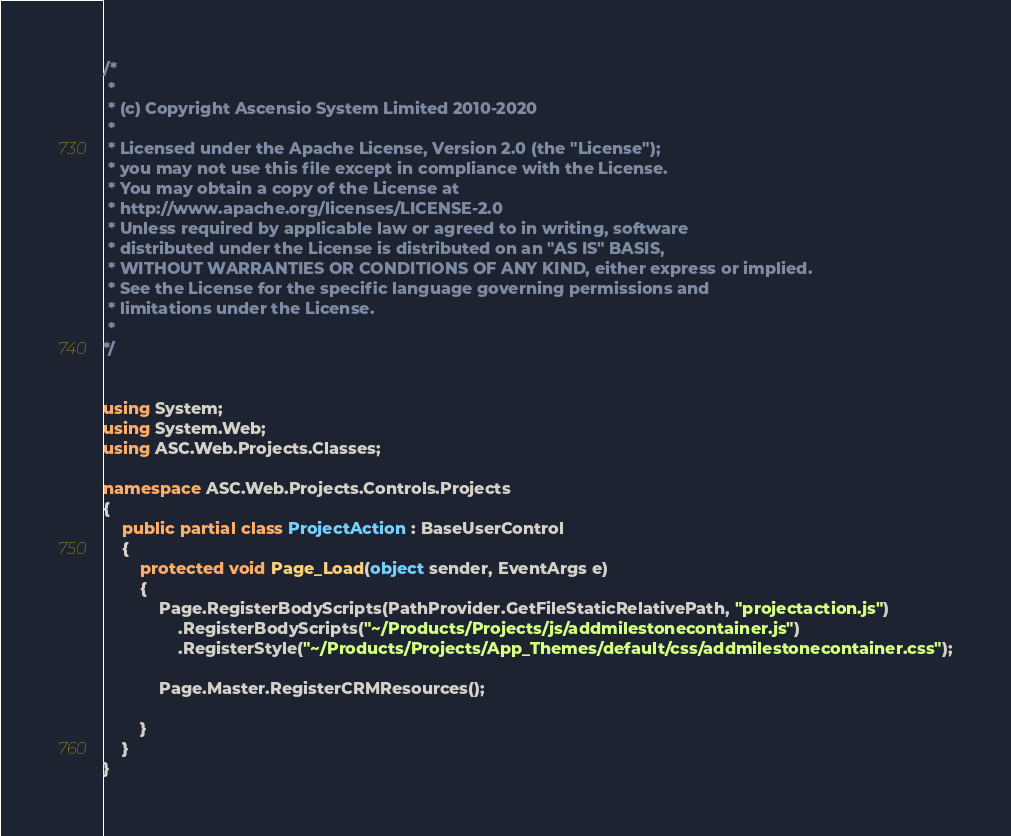Convert code to text. <code><loc_0><loc_0><loc_500><loc_500><_C#_>/*
 *
 * (c) Copyright Ascensio System Limited 2010-2020
 * 
 * Licensed under the Apache License, Version 2.0 (the "License");
 * you may not use this file except in compliance with the License.
 * You may obtain a copy of the License at
 * http://www.apache.org/licenses/LICENSE-2.0
 * Unless required by applicable law or agreed to in writing, software
 * distributed under the License is distributed on an "AS IS" BASIS,
 * WITHOUT WARRANTIES OR CONDITIONS OF ANY KIND, either express or implied.
 * See the License for the specific language governing permissions and
 * limitations under the License.
 *
*/


using System;
using System.Web;
using ASC.Web.Projects.Classes;

namespace ASC.Web.Projects.Controls.Projects
{
    public partial class ProjectAction : BaseUserControl
    {
        protected void Page_Load(object sender, EventArgs e)
        {
            Page.RegisterBodyScripts(PathProvider.GetFileStaticRelativePath, "projectaction.js")
                .RegisterBodyScripts("~/Products/Projects/js/addmilestonecontainer.js")
                .RegisterStyle("~/Products/Projects/App_Themes/default/css/addmilestonecontainer.css");

            Page.Master.RegisterCRMResources();

        }
    }
}</code> 